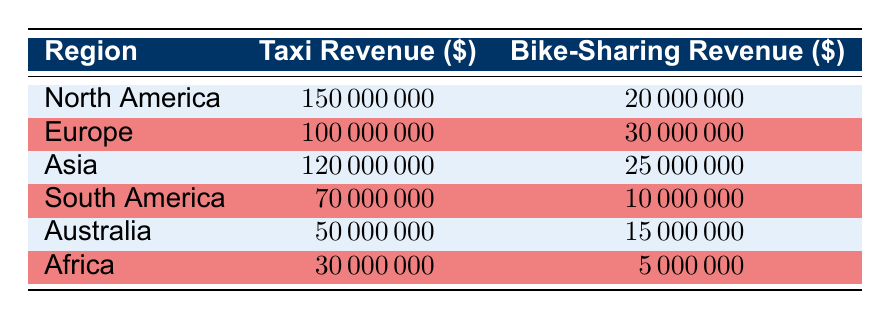What is the total taxi revenue across all regions? To find the total taxi revenue, I will add up the taxi revenue from each region: 150000000 (North America) + 100000000 (Europe) + 120000000 (Asia) + 70000000 (South America) + 50000000 (Australia) + 30000000 (Africa) = 570000000.
Answer: 570000000 What is the bike-sharing revenue in Europe? The bike-sharing revenue in Europe is clearly stated in the table and is 30000000.
Answer: 30000000 Which region has the highest taxi revenue? I will compare the taxi revenues from all regions: North America has 150000000, Europe has 100000000, Asia has 120000000, South America has 70000000, Australia has 50000000, and Africa has 30000000. North America has the highest revenue.
Answer: North America What is the difference between taxi revenue and bike-sharing revenue in Asia? To find the difference, I will subtract the bike-sharing revenue (25000000) from taxi revenue (120000000): 120000000 - 25000000 = 95000000.
Answer: 95000000 Is the bike-sharing revenue in North America greater than in Africa? North America's bike-sharing revenue is 20000000, while Africa's is 5000000. Since 20000000 is greater than 5000000, the statement is true.
Answer: Yes What is the average bike-sharing revenue across all regions? I will sum the bike-sharing revenue from each region: 20000000 (North America) + 30000000 (Europe) + 25000000 (Asia) + 10000000 (South America) + 15000000 (Australia) + 5000 (Africa) = 100000000. There are 6 regions, so the average is 100000000 / 6 ≈ 16666667.
Answer: 16666667 How much more revenue do taxis generate compared to bike-sharing services in South America? Taxi revenue in South America is 70000000 and bike-sharing revenue is 10000000. To find out how much more, I will subtract bike-sharing revenue from taxi revenue: 70000000 - 10000000 = 60000000.
Answer: 60000000 Do all regions have more revenue from taxis than bike-sharing services? I will check each region's revenue: North America, Europe, Asia, South America, Australia, and Africa all show Taxi Revenue > Bike-Sharing Revenue. Thus, the statement is true.
Answer: Yes In which region is the bike-sharing revenue the lowest? Looking through each bike-sharing revenue: North America (20000000), Europe (30000000), Asia (25000000), South America (10000000), Australia (15000000), and Africa (5000). Africa has the lowest bike-sharing revenue.
Answer: Africa 